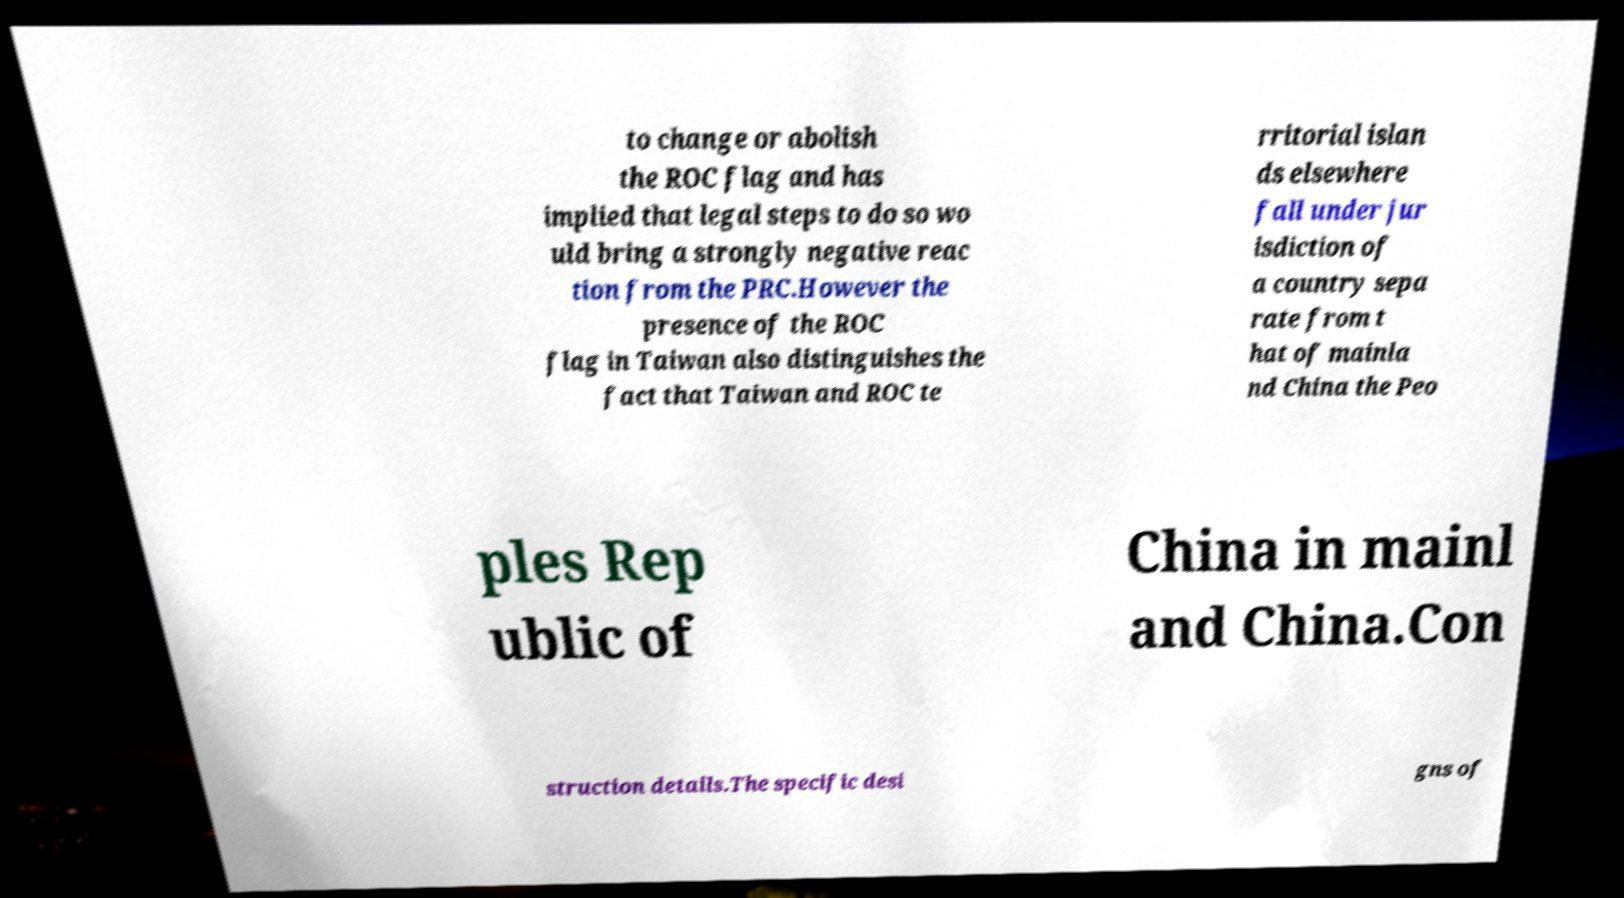There's text embedded in this image that I need extracted. Can you transcribe it verbatim? to change or abolish the ROC flag and has implied that legal steps to do so wo uld bring a strongly negative reac tion from the PRC.However the presence of the ROC flag in Taiwan also distinguishes the fact that Taiwan and ROC te rritorial islan ds elsewhere fall under jur isdiction of a country sepa rate from t hat of mainla nd China the Peo ples Rep ublic of China in mainl and China.Con struction details.The specific desi gns of 